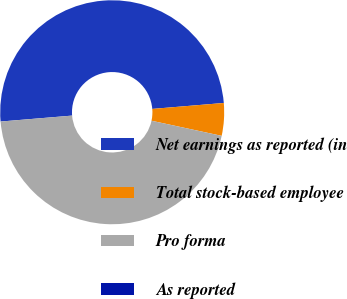Convert chart. <chart><loc_0><loc_0><loc_500><loc_500><pie_chart><fcel>Net earnings as reported (in<fcel>Total stock-based employee<fcel>Pro forma<fcel>As reported<nl><fcel>50.0%<fcel>4.7%<fcel>45.3%<fcel>0.0%<nl></chart> 